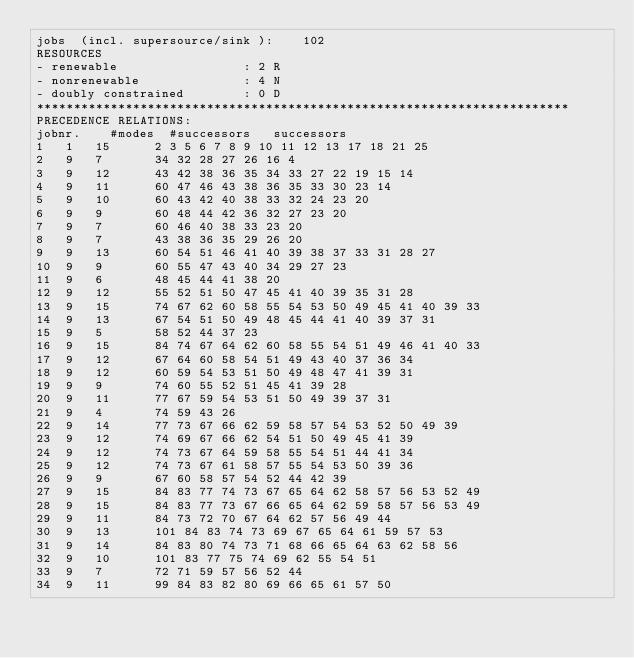Convert code to text. <code><loc_0><loc_0><loc_500><loc_500><_ObjectiveC_>jobs  (incl. supersource/sink ):	102
RESOURCES
- renewable                 : 2 R
- nonrenewable              : 4 N
- doubly constrained        : 0 D
************************************************************************
PRECEDENCE RELATIONS:
jobnr.    #modes  #successors   successors
1	1	15		2 3 5 6 7 8 9 10 11 12 13 17 18 21 25 
2	9	7		34 32 28 27 26 16 4 
3	9	12		43 42 38 36 35 34 33 27 22 19 15 14 
4	9	11		60 47 46 43 38 36 35 33 30 23 14 
5	9	10		60 43 42 40 38 33 32 24 23 20 
6	9	9		60 48 44 42 36 32 27 23 20 
7	9	7		60 46 40 38 33 23 20 
8	9	7		43 38 36 35 29 26 20 
9	9	13		60 54 51 46 41 40 39 38 37 33 31 28 27 
10	9	9		60 55 47 43 40 34 29 27 23 
11	9	6		48 45 44 41 38 20 
12	9	12		55 52 51 50 47 45 41 40 39 35 31 28 
13	9	15		74 67 62 60 58 55 54 53 50 49 45 41 40 39 33 
14	9	13		67 54 51 50 49 48 45 44 41 40 39 37 31 
15	9	5		58 52 44 37 23 
16	9	15		84 74 67 64 62 60 58 55 54 51 49 46 41 40 33 
17	9	12		67 64 60 58 54 51 49 43 40 37 36 34 
18	9	12		60 59 54 53 51 50 49 48 47 41 39 31 
19	9	9		74 60 55 52 51 45 41 39 28 
20	9	11		77 67 59 54 53 51 50 49 39 37 31 
21	9	4		74 59 43 26 
22	9	14		77 73 67 66 62 59 58 57 54 53 52 50 49 39 
23	9	12		74 69 67 66 62 54 51 50 49 45 41 39 
24	9	12		74 73 67 64 59 58 55 54 51 44 41 34 
25	9	12		74 73 67 61 58 57 55 54 53 50 39 36 
26	9	9		67 60 58 57 54 52 44 42 39 
27	9	15		84 83 77 74 73 67 65 64 62 58 57 56 53 52 49 
28	9	15		84 83 77 73 67 66 65 64 62 59 58 57 56 53 49 
29	9	11		84 73 72 70 67 64 62 57 56 49 44 
30	9	13		101 84 83 74 73 69 67 65 64 61 59 57 53 
31	9	14		84 83 80 74 73 71 68 66 65 64 63 62 58 56 
32	9	10		101 83 77 75 74 69 62 55 54 51 
33	9	7		72 71 59 57 56 52 44 
34	9	11		99 84 83 82 80 69 66 65 61 57 50 </code> 